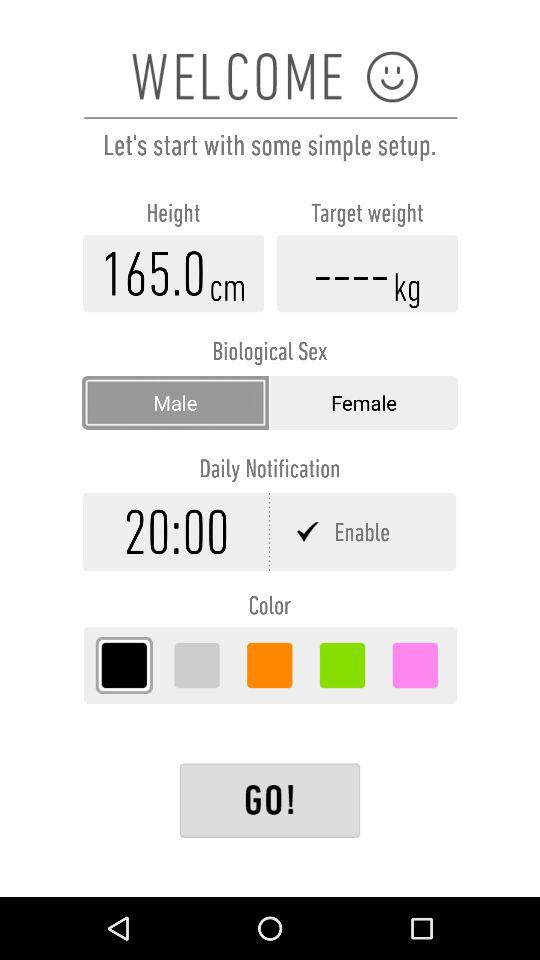What is the selected color? The selected color is black. 